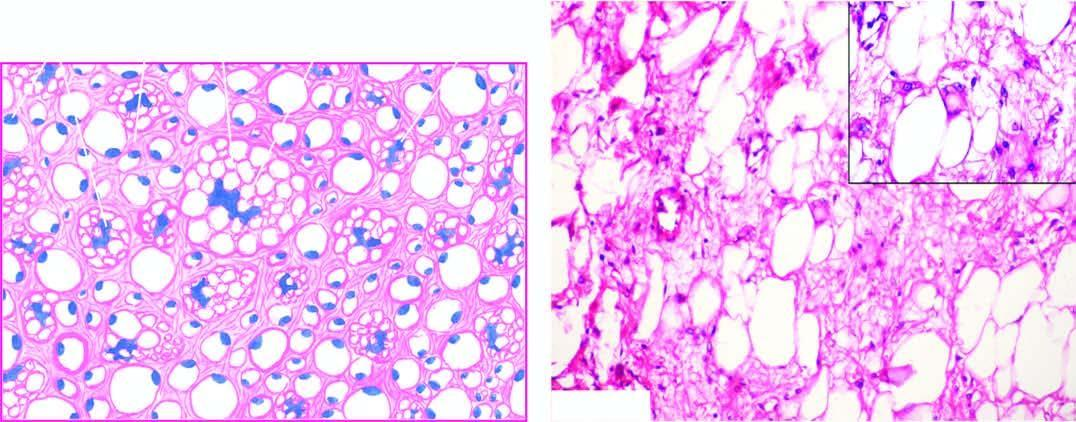does the particle show characteristic, univacuolated and multivacuolated lipoblasts with bizarre nuclei?
Answer the question using a single word or phrase. No 